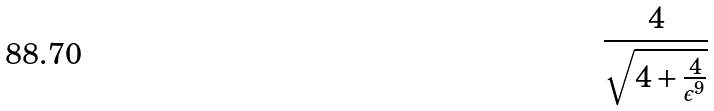<formula> <loc_0><loc_0><loc_500><loc_500>\frac { 4 } { \sqrt { 4 + \frac { 4 } { \epsilon ^ { 9 } } } }</formula> 